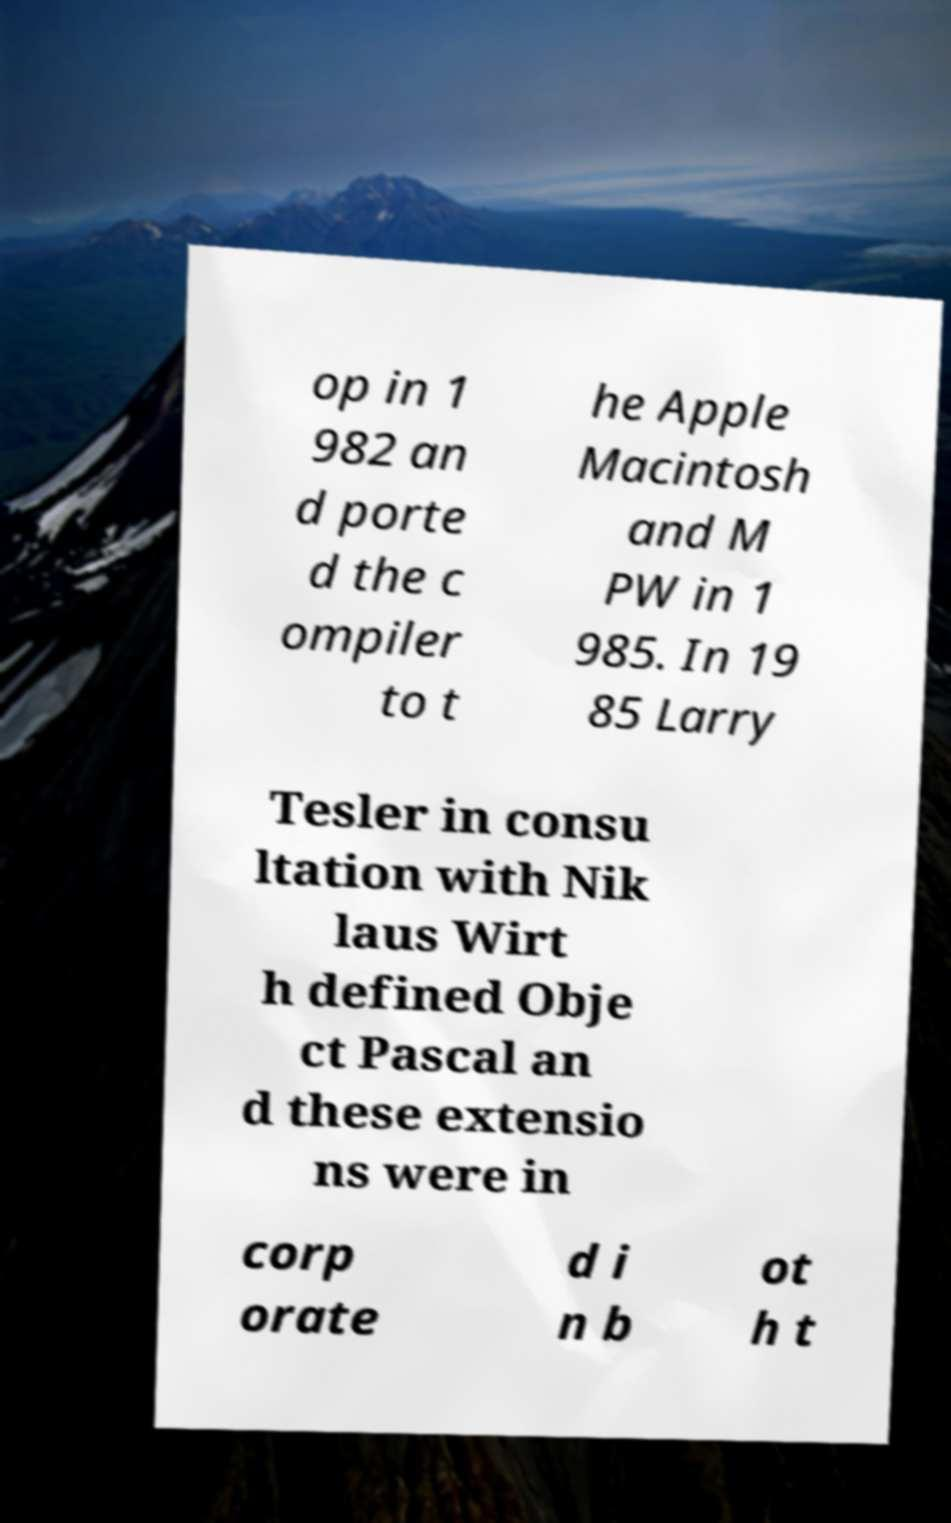Can you read and provide the text displayed in the image?This photo seems to have some interesting text. Can you extract and type it out for me? op in 1 982 an d porte d the c ompiler to t he Apple Macintosh and M PW in 1 985. In 19 85 Larry Tesler in consu ltation with Nik laus Wirt h defined Obje ct Pascal an d these extensio ns were in corp orate d i n b ot h t 